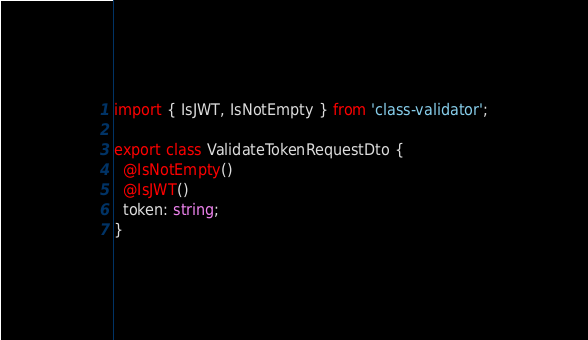Convert code to text. <code><loc_0><loc_0><loc_500><loc_500><_TypeScript_>import { IsJWT, IsNotEmpty } from 'class-validator';

export class ValidateTokenRequestDto {
  @IsNotEmpty()
  @IsJWT()
  token: string;
}
</code> 